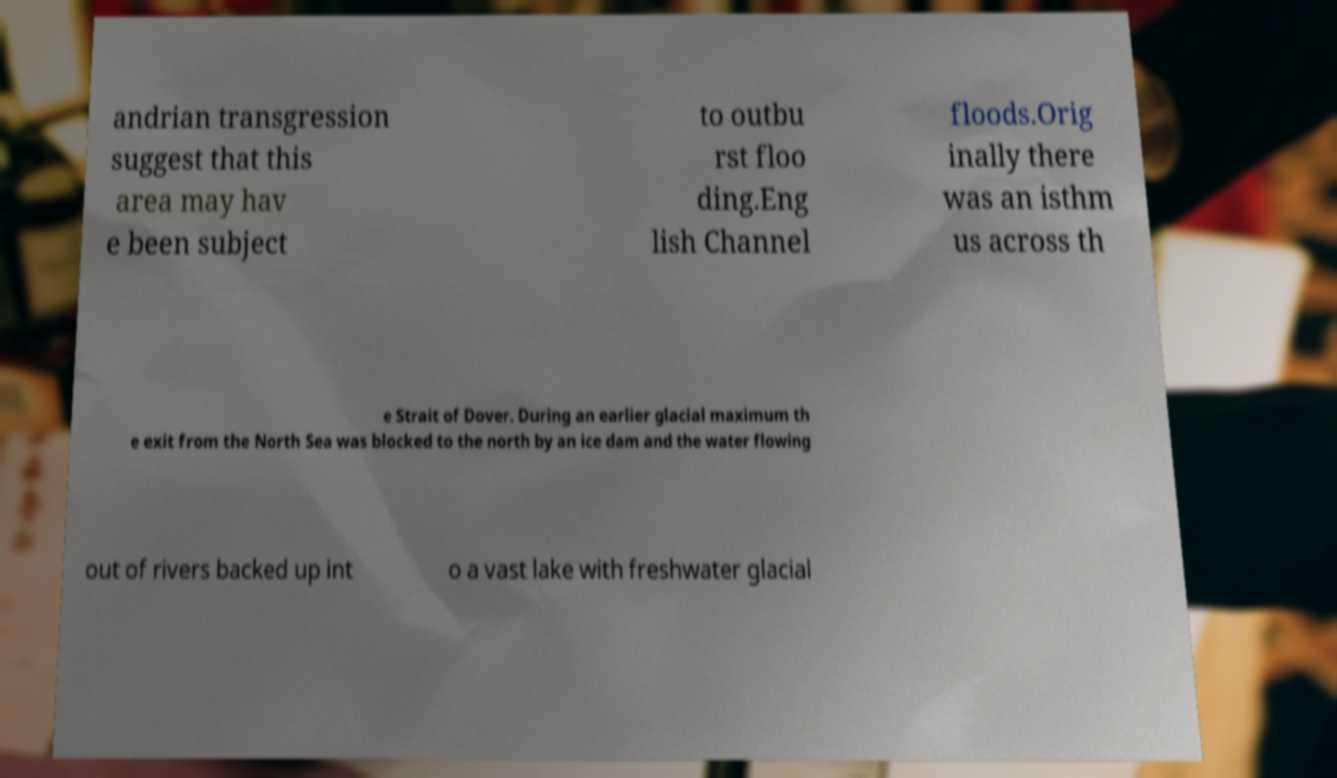Can you accurately transcribe the text from the provided image for me? andrian transgression suggest that this area may hav e been subject to outbu rst floo ding.Eng lish Channel floods.Orig inally there was an isthm us across th e Strait of Dover. During an earlier glacial maximum th e exit from the North Sea was blocked to the north by an ice dam and the water flowing out of rivers backed up int o a vast lake with freshwater glacial 